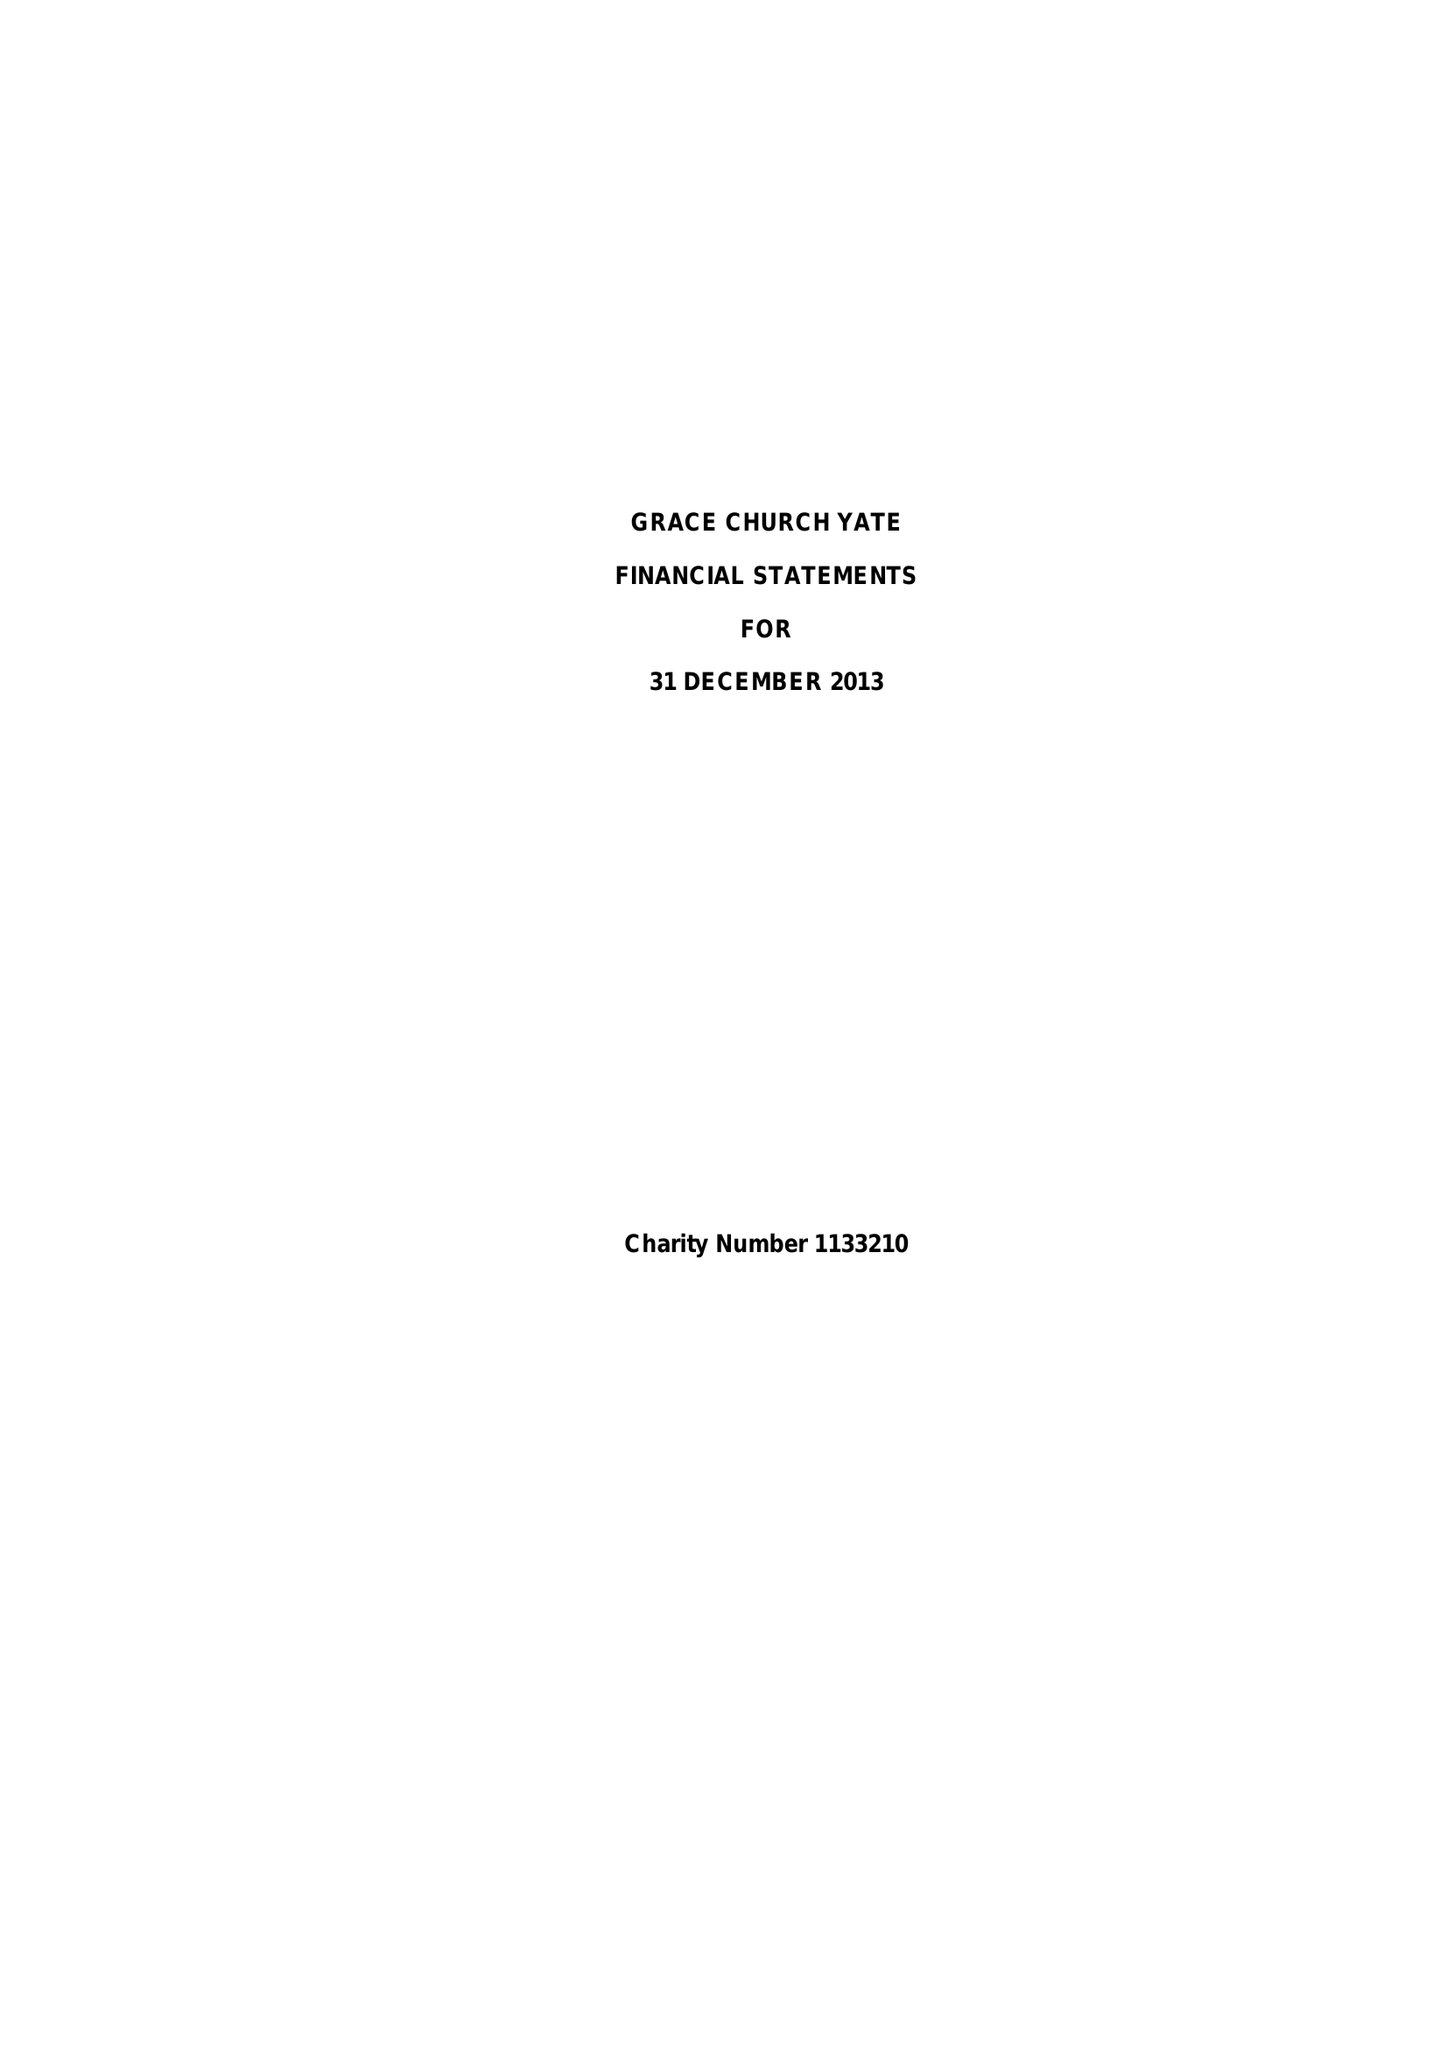What is the value for the income_annually_in_british_pounds?
Answer the question using a single word or phrase. 497884.00 